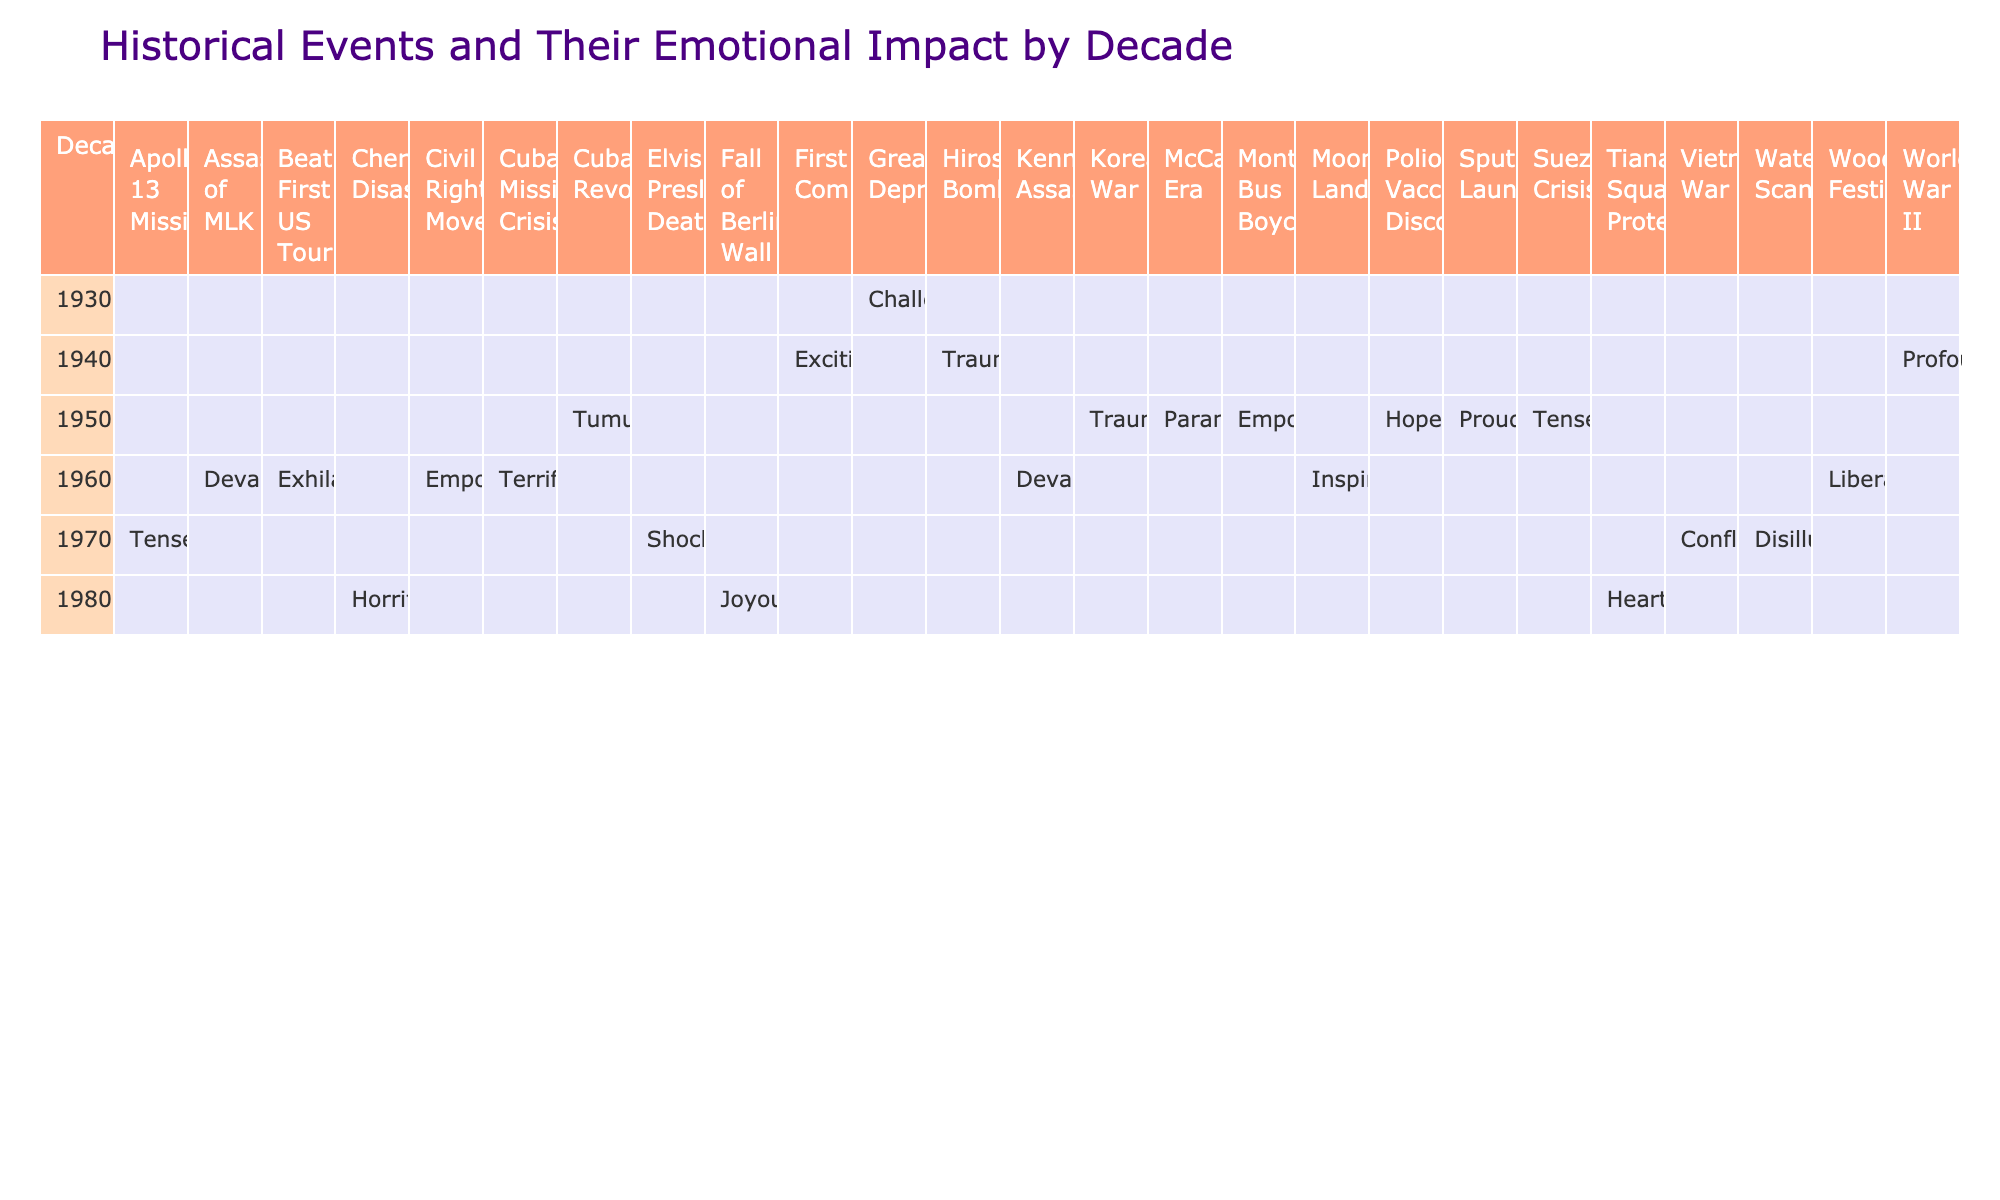What is the emotional impact associated with the Civil Rights Movement in the 1960s? The table shows that the emotional impact of the Civil Rights Movement, as mentioned in the interviews, is categorized as "Empowering." I looked at the row for the 1960s and found the entry for this specific event.
Answer: Empowering Which decade saw the event known as the Moon Landing? The table categorizes the Moon Landing under the 1960s. By locating this event in the column of events and checking which decade it belongs to, we find it listed under the 1960s.
Answer: 1960s How many events in the 1970s have an emotional impact categorized as "Tense"? In the 1970s section of the table, the only events with an emotional impact categorized as "Tense" are the Apollo 13 Mission. By examining the events listed and their associated emotional impacts, I conclude that there is one event with the specified emotional impact.
Answer: 1 Is there an event from the 1980s that is categorized as "Horrifying"? I checked the 1980s section of the table for any events categorized as "Horrifying." The Chernobyl Disaster is listed with that emotional impact. Therefore, the answer is yes; there is such an event.
Answer: Yes Which decade has the most significant number of events mentioned? By counting the number of events under each decade in the table, I find that the 1960s have the highest number of events listed (which are 6 in total). Thus, the 1960s is the decade with the most events recorded.
Answer: 1960s What is the emotional impact of the event known as the Fall of Berlin Wall? The table indicates that the Fall of Berlin Wall, which is listed under the 1980s, has an emotional impact categorized as "Joyous." Hence, that is the answer regarding its emotional impact.
Answer: Joyous How many events related to wars occurred in the 1970s? In the 1970s, I examined the events related to wars and found that there are two: the Vietnam War and the Apollo 13 Mission (though the latter isn’t related to a war, it was emotionally tense). Therefore, counting only the Vietnam War, there is one relevant event in this context.
Answer: 1 Was the emotional impact of the Hiroshima Bombing in the 1940s categorized as "Traumatic"? In the 1940s section of the table, the Hiroshima Bombing is listed with the emotional impact of "Traumatic." Therefore, this statement is true based on the information found in the table.
Answer: Yes 